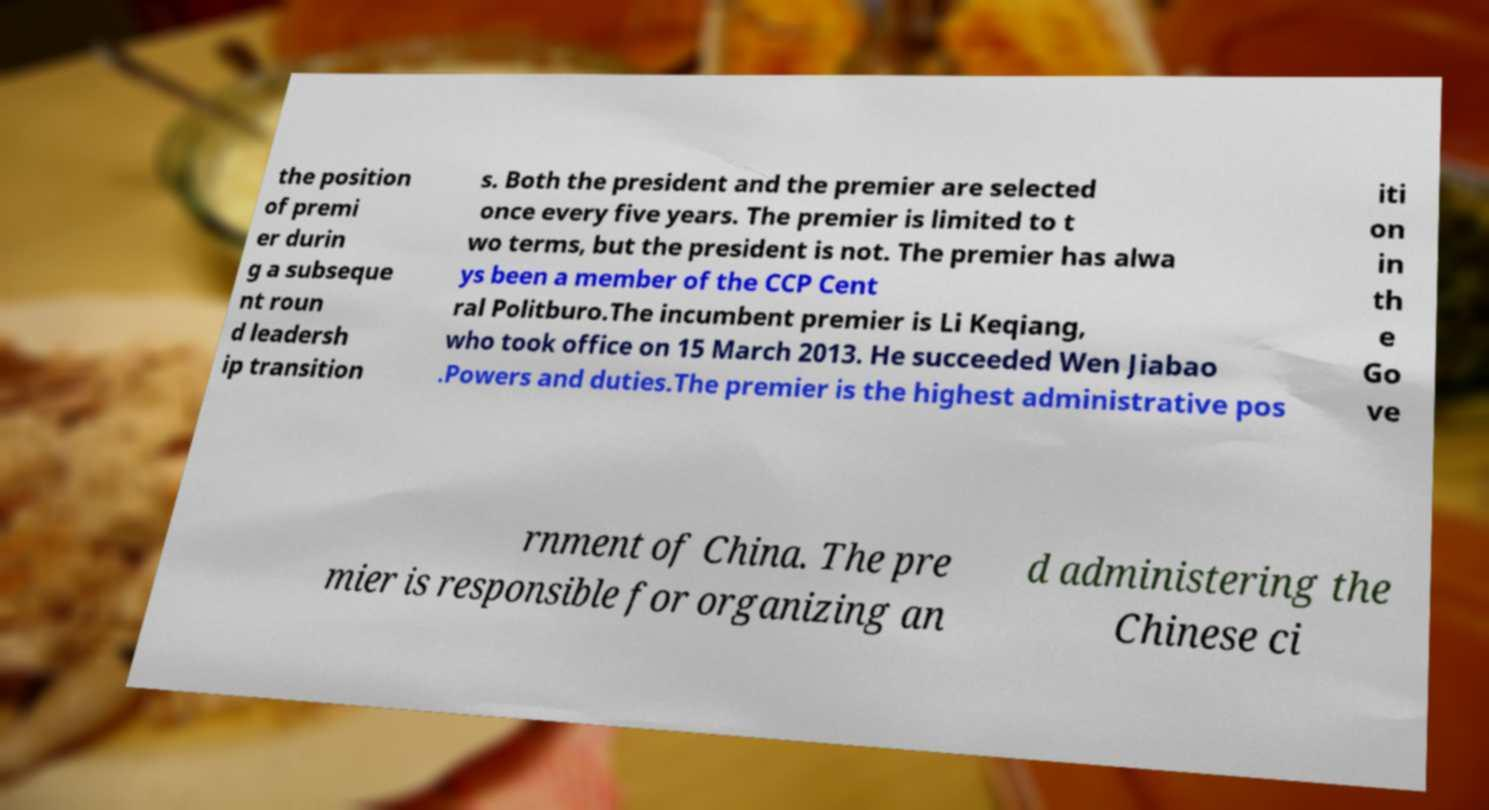Can you accurately transcribe the text from the provided image for me? the position of premi er durin g a subseque nt roun d leadersh ip transition s. Both the president and the premier are selected once every five years. The premier is limited to t wo terms, but the president is not. The premier has alwa ys been a member of the CCP Cent ral Politburo.The incumbent premier is Li Keqiang, who took office on 15 March 2013. He succeeded Wen Jiabao .Powers and duties.The premier is the highest administrative pos iti on in th e Go ve rnment of China. The pre mier is responsible for organizing an d administering the Chinese ci 